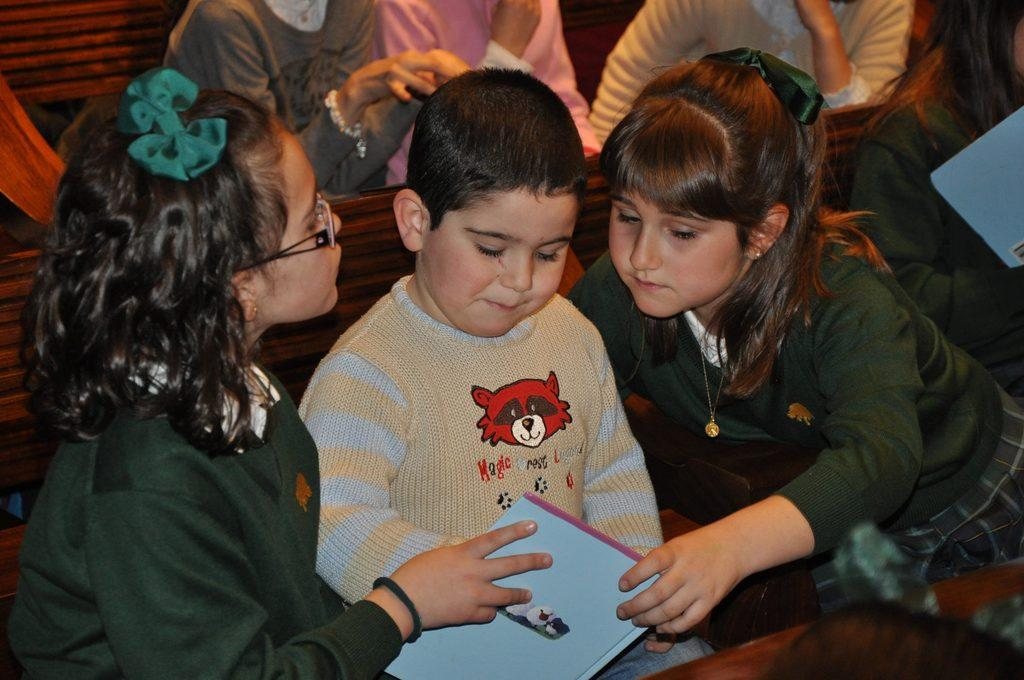Who is present in the image? There are kids in the image. What object can be seen at the bottom of the image? There is a book at the bottom of the image. What type of table is visible in the image? There is no table present in the image. Are the kids in the image related as brothers? The relationship between the kids in the image cannot be determined from the provided facts. 